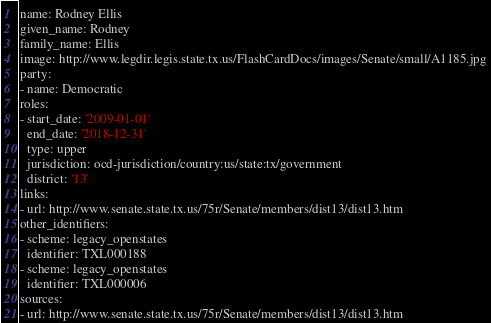<code> <loc_0><loc_0><loc_500><loc_500><_YAML_>name: Rodney Ellis
given_name: Rodney
family_name: Ellis
image: http://www.legdir.legis.state.tx.us/FlashCardDocs/images/Senate/small/A1185.jpg
party:
- name: Democratic
roles:
- start_date: '2009-01-01'
  end_date: '2018-12-31'
  type: upper
  jurisdiction: ocd-jurisdiction/country:us/state:tx/government
  district: '13'
links:
- url: http://www.senate.state.tx.us/75r/Senate/members/dist13/dist13.htm
other_identifiers:
- scheme: legacy_openstates
  identifier: TXL000188
- scheme: legacy_openstates
  identifier: TXL000006
sources:
- url: http://www.senate.state.tx.us/75r/Senate/members/dist13/dist13.htm
</code> 